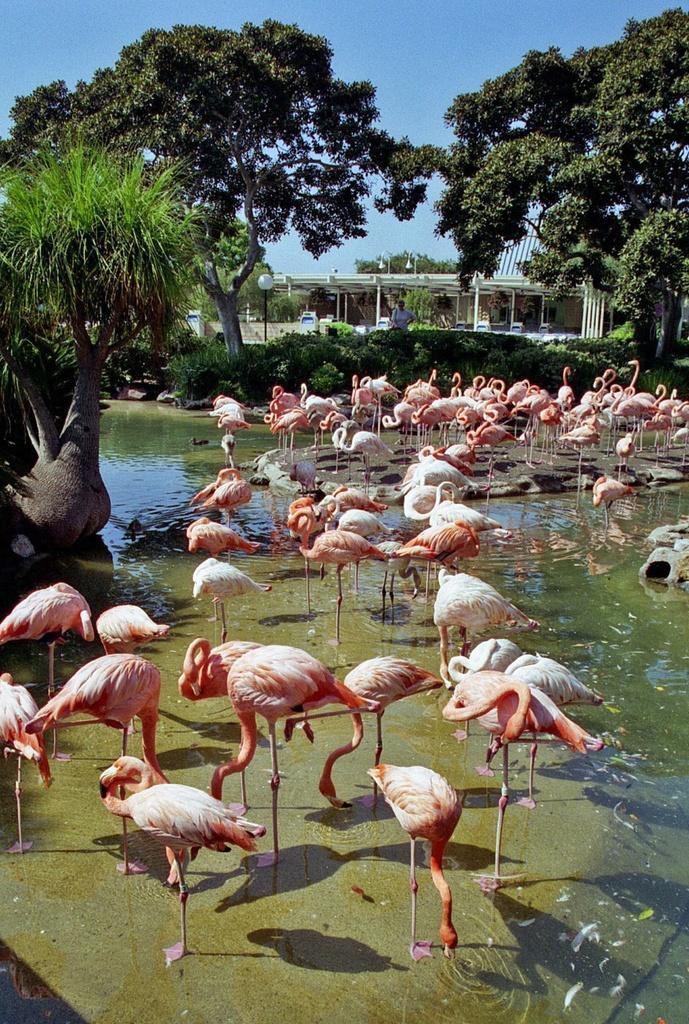Please provide a concise description of this image. In the picture I can see flamingo birds in the water, we can see trees, light poles, a person standing there, we can see house and the sky in the background. 